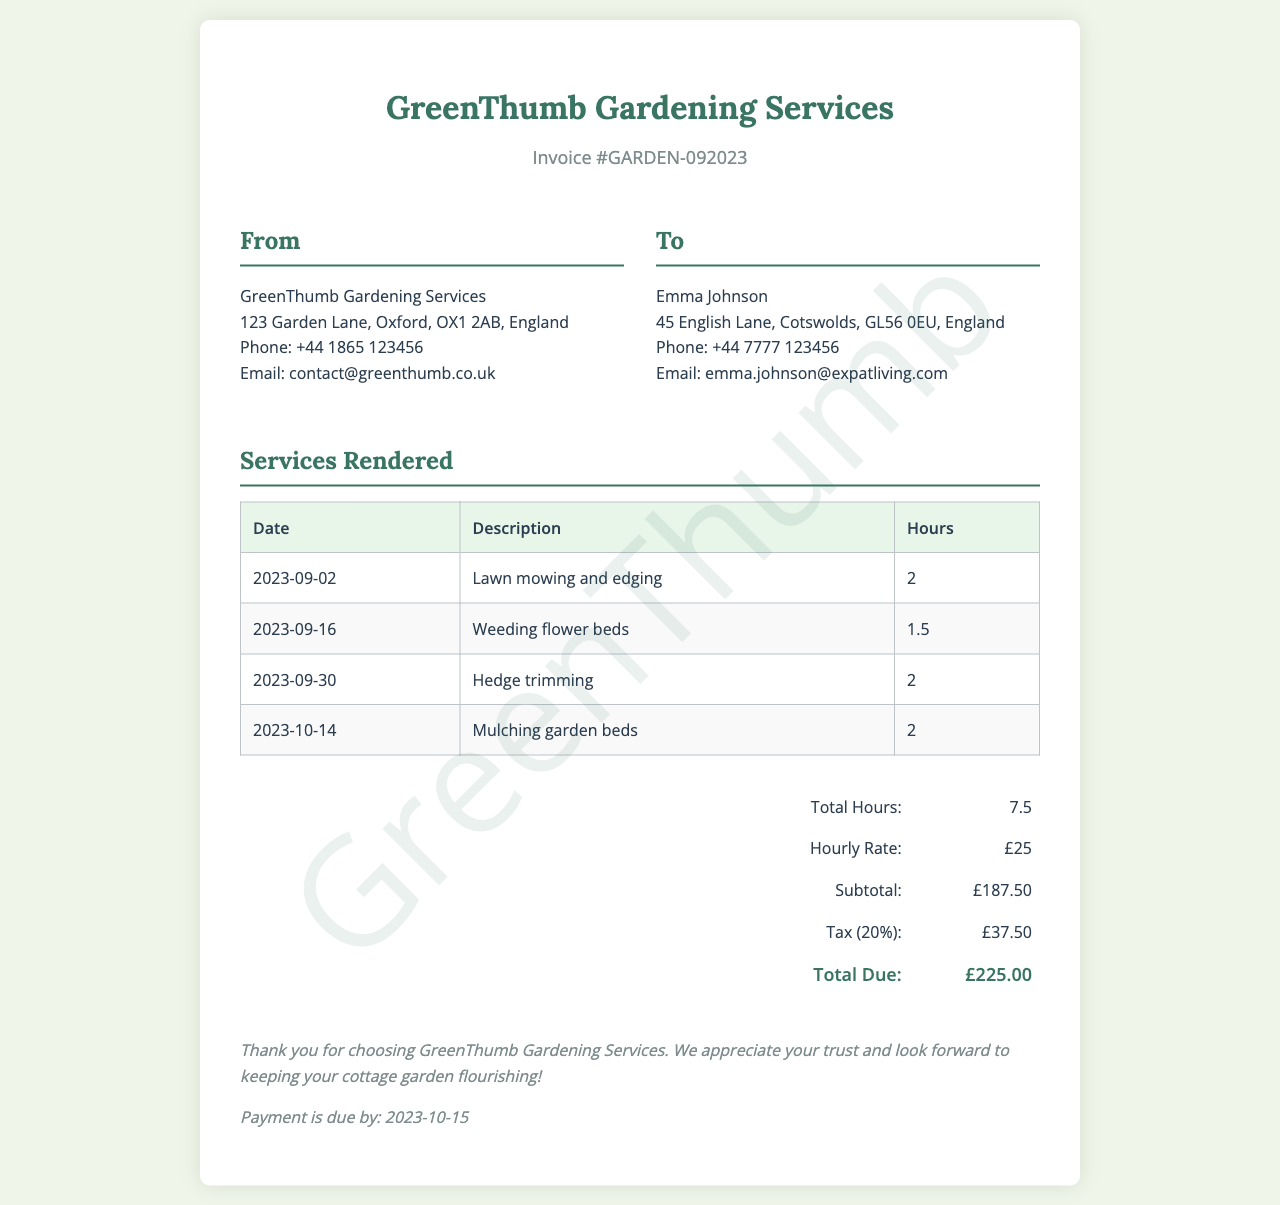What is the invoice number? The invoice number is displayed prominently at the top of the document.
Answer: GARDEN-092023 What is the total due amount? The total due amount is summarized at the bottom of the invoice.
Answer: £225.00 How many hours were worked in total? The total hours worked are calculated and stated in the total section of the invoice.
Answer: 7.5 What services were rendered on September 2nd? The specific service rendered on that date is listed in the services table.
Answer: Lawn mowing and edging What is the hourly rate for the gardening services? The hourly rate can be found in the total section of the invoice.
Answer: £25 How many services were provided in September? By counting the entries in the services rendered section for September, we find the count.
Answer: 2 What is the tax percentage applied to the subtotal? The tax percentage is mentioned alongside the subtotal in the total section.
Answer: 20% Which service was performed last? The last service is listed at the bottom of the services rendered table.
Answer: Mulching garden beds 